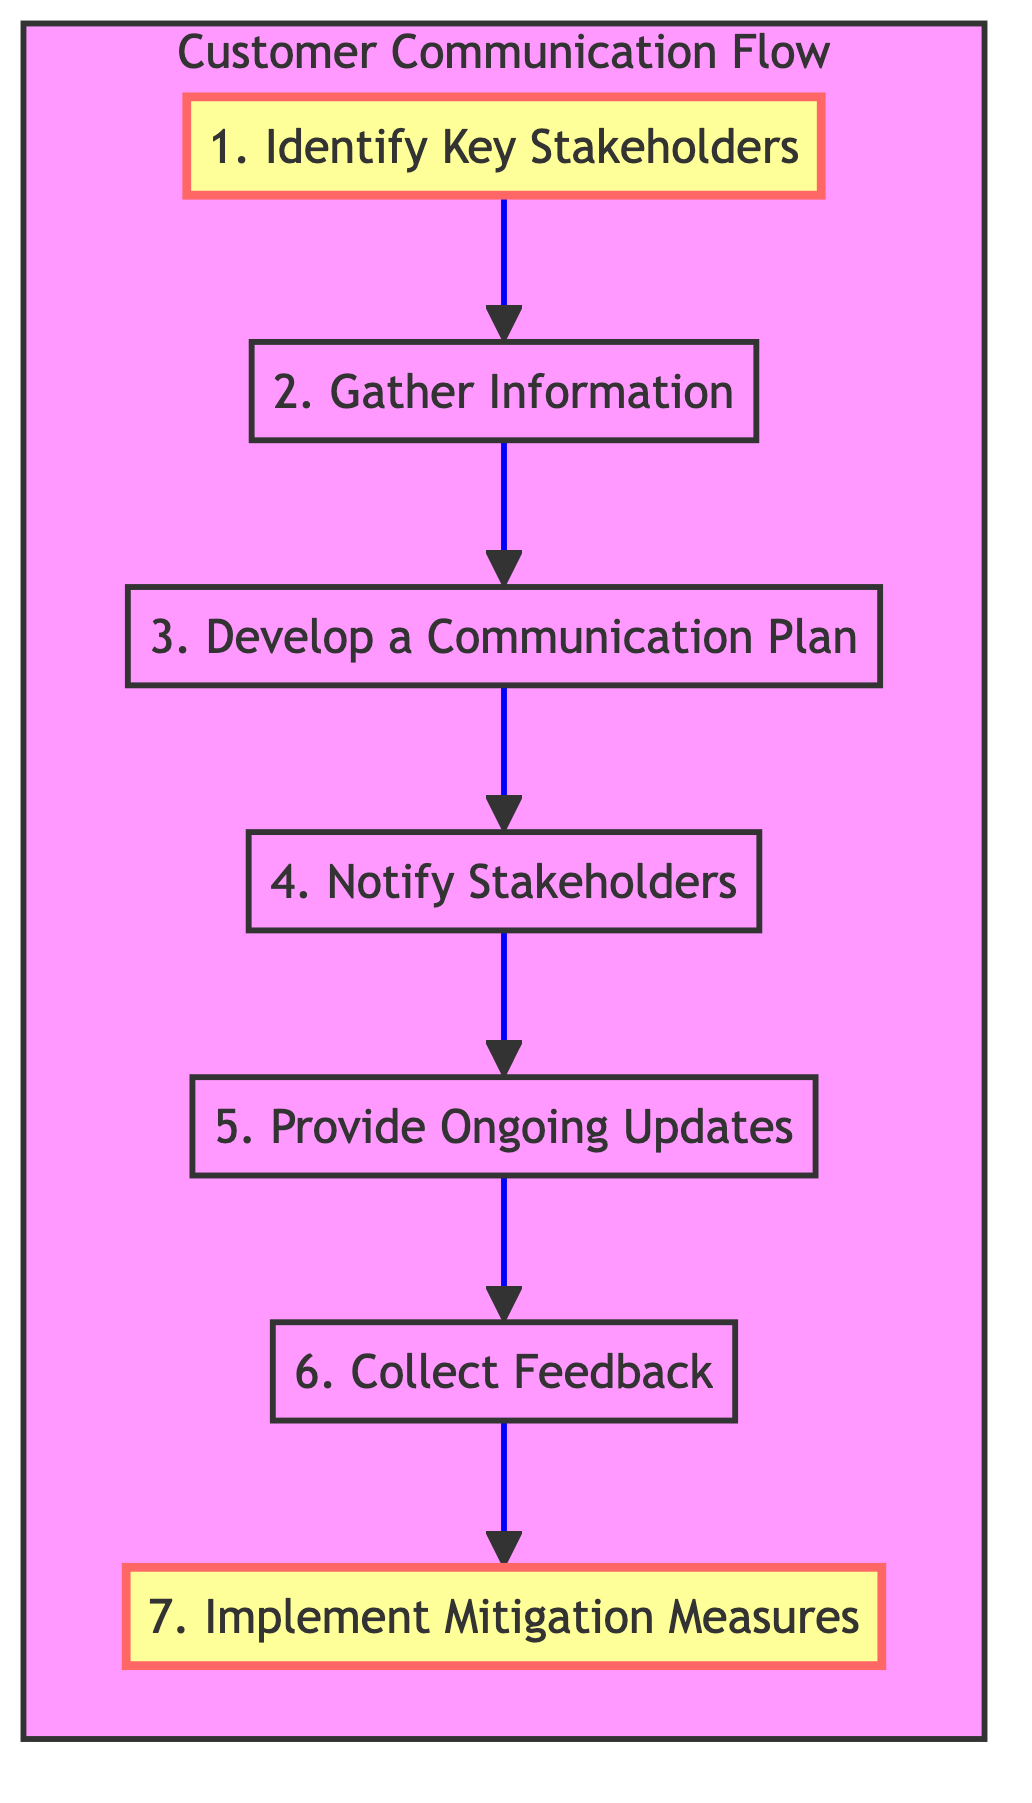What is the first step in the communication process? The first step in the flow chart is "Identify Key Stakeholders," which is indicated at the top of the diagram, establishing the starting point of the process.
Answer: Identify Key Stakeholders How many total steps are in the diagram? There are seven steps shown in the flow chart, enumerated from 1 to 7, indicating the complete process involved in customer communication about road construction.
Answer: 7 What action comes after collecting feedback? After "Collect Feedback," the next action outlined in the flow chart is "Implement Mitigation Measures," indicating that feedback leads directly to mitigation efforts.
Answer: Implement Mitigation Measures Which step focuses on informing customers about construction impacts? The step that focuses on informing customers about construction impacts is "Notify Stakeholders." This step directly involves the communication of information to the relevant parties.
Answer: Notify Stakeholders What is the last step in the process? The last step in the process, as shown in the flow chart, is "Implement Mitigation Measures," which represents the final action taken based on stakeholder feedback.
Answer: Implement Mitigation Measures What are the communication methods outlined in the plan? Although not explicitly detailed in the flow chart, the "Develop a Communication Plan" step suggests that various methods will be utilized, such as email, social media, and local signage, for informing stakeholders.
Answer: Email, social media, local signage What is the main purpose of the "Gather Information" step? The main purpose of the "Gather Information" step is to collect essential details about the road construction, including the timeline, duration, and access impacts, which are critical for effective communication.
Answer: Collect details about the road construction timeline, duration, and impact on access 